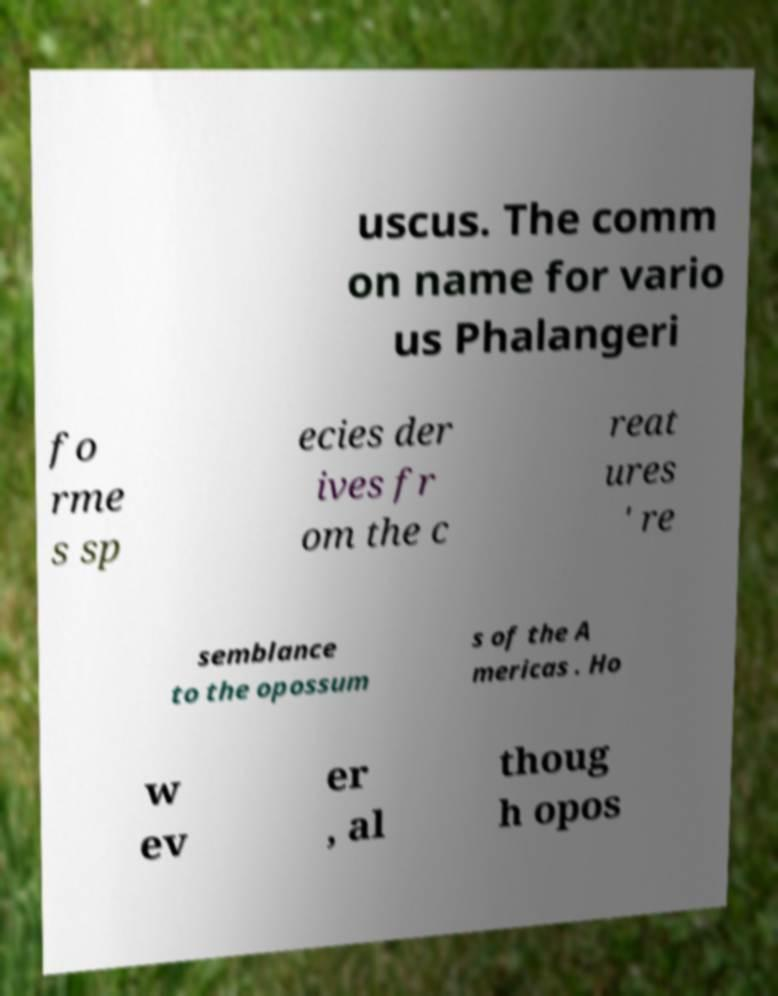Can you accurately transcribe the text from the provided image for me? uscus. The comm on name for vario us Phalangeri fo rme s sp ecies der ives fr om the c reat ures ' re semblance to the opossum s of the A mericas . Ho w ev er , al thoug h opos 